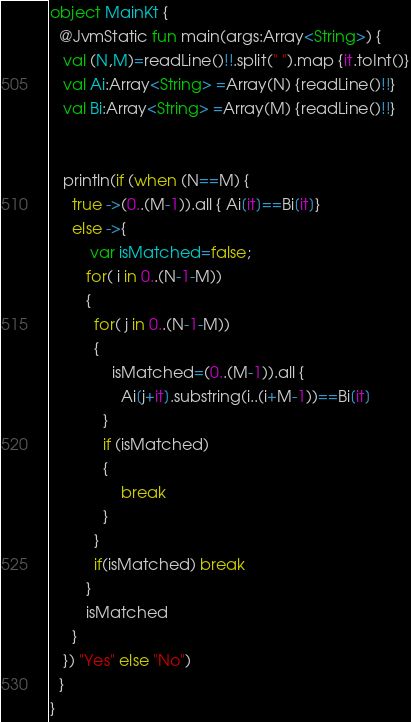<code> <loc_0><loc_0><loc_500><loc_500><_Kotlin_>
object MainKt {
  @JvmStatic fun main(args:Array<String>) {
   val (N,M)=readLine()!!.split(" ").map {it.toInt()}
   val Ai:Array<String> =Array(N) {readLine()!!}
   val Bi:Array<String> =Array(M) {readLine()!!}
 

   println(if (when (N==M) {
     true ->(0..(M-1)).all { Ai[it]==Bi[it]}
     else ->{
         var isMatched=false;
        for( i in 0..(N-1-M))
        {
          for( j in 0..(N-1-M))
          {
              isMatched=(0..(M-1)).all {
                Ai[j+it].substring(i..(i+M-1))==Bi[it]
            }
            if (isMatched)
            {
                break 
            }
          }
          if(isMatched) break
        }
        isMatched
     }
   }) "Yes" else "No")
  }
}</code> 